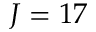Convert formula to latex. <formula><loc_0><loc_0><loc_500><loc_500>J = 1 7</formula> 